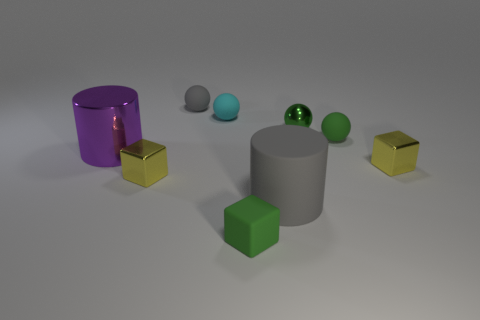Subtract all small cyan rubber balls. How many balls are left? 3 Subtract all green balls. How many balls are left? 2 Subtract 1 blocks. How many blocks are left? 2 Add 1 small green cubes. How many objects exist? 10 Subtract all purple spheres. Subtract all gray cylinders. How many spheres are left? 4 Subtract all red balls. How many green cubes are left? 1 Subtract all shiny blocks. Subtract all large purple shiny objects. How many objects are left? 6 Add 1 green rubber blocks. How many green rubber blocks are left? 2 Add 1 green objects. How many green objects exist? 4 Subtract 0 purple spheres. How many objects are left? 9 